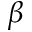Convert formula to latex. <formula><loc_0><loc_0><loc_500><loc_500>\beta</formula> 